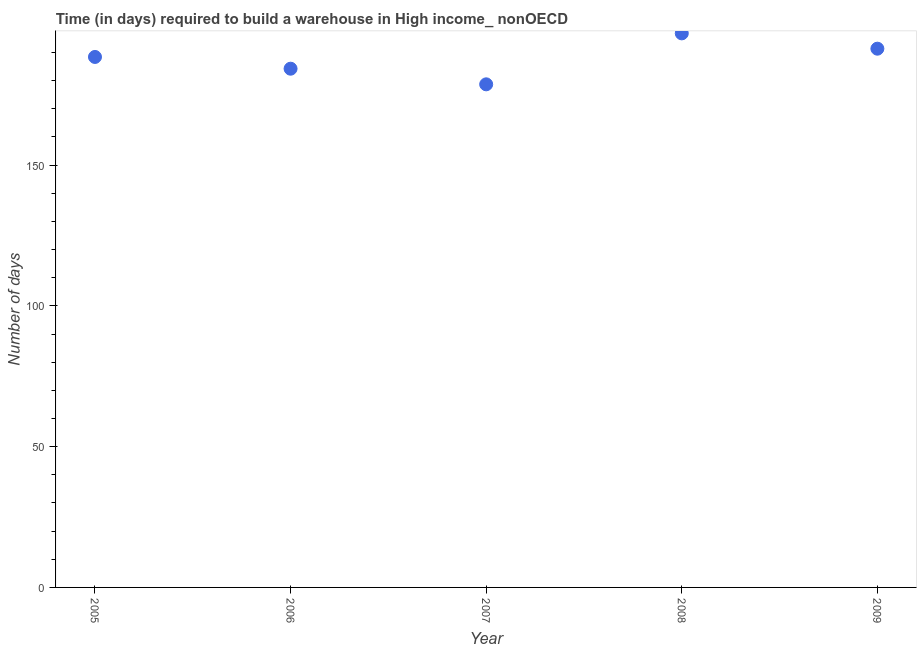What is the time required to build a warehouse in 2008?
Offer a very short reply. 196.77. Across all years, what is the maximum time required to build a warehouse?
Provide a succinct answer. 196.77. Across all years, what is the minimum time required to build a warehouse?
Provide a succinct answer. 178.67. In which year was the time required to build a warehouse maximum?
Your answer should be compact. 2008. In which year was the time required to build a warehouse minimum?
Offer a very short reply. 2007. What is the sum of the time required to build a warehouse?
Keep it short and to the point. 939.4. What is the difference between the time required to build a warehouse in 2005 and 2008?
Your response must be concise. -8.38. What is the average time required to build a warehouse per year?
Provide a short and direct response. 187.88. What is the median time required to build a warehouse?
Keep it short and to the point. 188.39. What is the ratio of the time required to build a warehouse in 2005 to that in 2006?
Your answer should be compact. 1.02. Is the time required to build a warehouse in 2005 less than that in 2006?
Your answer should be compact. No. What is the difference between the highest and the second highest time required to build a warehouse?
Keep it short and to the point. 5.44. Is the sum of the time required to build a warehouse in 2006 and 2009 greater than the maximum time required to build a warehouse across all years?
Give a very brief answer. Yes. What is the difference between the highest and the lowest time required to build a warehouse?
Keep it short and to the point. 18.1. In how many years, is the time required to build a warehouse greater than the average time required to build a warehouse taken over all years?
Your response must be concise. 3. How many years are there in the graph?
Make the answer very short. 5. Does the graph contain any zero values?
Provide a succinct answer. No. What is the title of the graph?
Offer a very short reply. Time (in days) required to build a warehouse in High income_ nonOECD. What is the label or title of the X-axis?
Your answer should be compact. Year. What is the label or title of the Y-axis?
Offer a very short reply. Number of days. What is the Number of days in 2005?
Offer a terse response. 188.39. What is the Number of days in 2006?
Give a very brief answer. 184.22. What is the Number of days in 2007?
Your answer should be compact. 178.67. What is the Number of days in 2008?
Your answer should be very brief. 196.77. What is the Number of days in 2009?
Offer a very short reply. 191.33. What is the difference between the Number of days in 2005 and 2006?
Ensure brevity in your answer.  4.17. What is the difference between the Number of days in 2005 and 2007?
Provide a short and direct response. 9.72. What is the difference between the Number of days in 2005 and 2008?
Offer a terse response. -8.38. What is the difference between the Number of days in 2005 and 2009?
Keep it short and to the point. -2.94. What is the difference between the Number of days in 2006 and 2007?
Make the answer very short. 5.55. What is the difference between the Number of days in 2006 and 2008?
Your answer should be very brief. -12.55. What is the difference between the Number of days in 2006 and 2009?
Your answer should be compact. -7.11. What is the difference between the Number of days in 2007 and 2008?
Your response must be concise. -18.1. What is the difference between the Number of days in 2007 and 2009?
Offer a very short reply. -12.66. What is the difference between the Number of days in 2008 and 2009?
Provide a succinct answer. 5.44. What is the ratio of the Number of days in 2005 to that in 2006?
Your answer should be very brief. 1.02. What is the ratio of the Number of days in 2005 to that in 2007?
Provide a short and direct response. 1.05. What is the ratio of the Number of days in 2005 to that in 2008?
Ensure brevity in your answer.  0.96. What is the ratio of the Number of days in 2006 to that in 2007?
Your answer should be very brief. 1.03. What is the ratio of the Number of days in 2006 to that in 2008?
Give a very brief answer. 0.94. What is the ratio of the Number of days in 2006 to that in 2009?
Give a very brief answer. 0.96. What is the ratio of the Number of days in 2007 to that in 2008?
Your answer should be very brief. 0.91. What is the ratio of the Number of days in 2007 to that in 2009?
Keep it short and to the point. 0.93. What is the ratio of the Number of days in 2008 to that in 2009?
Your response must be concise. 1.03. 